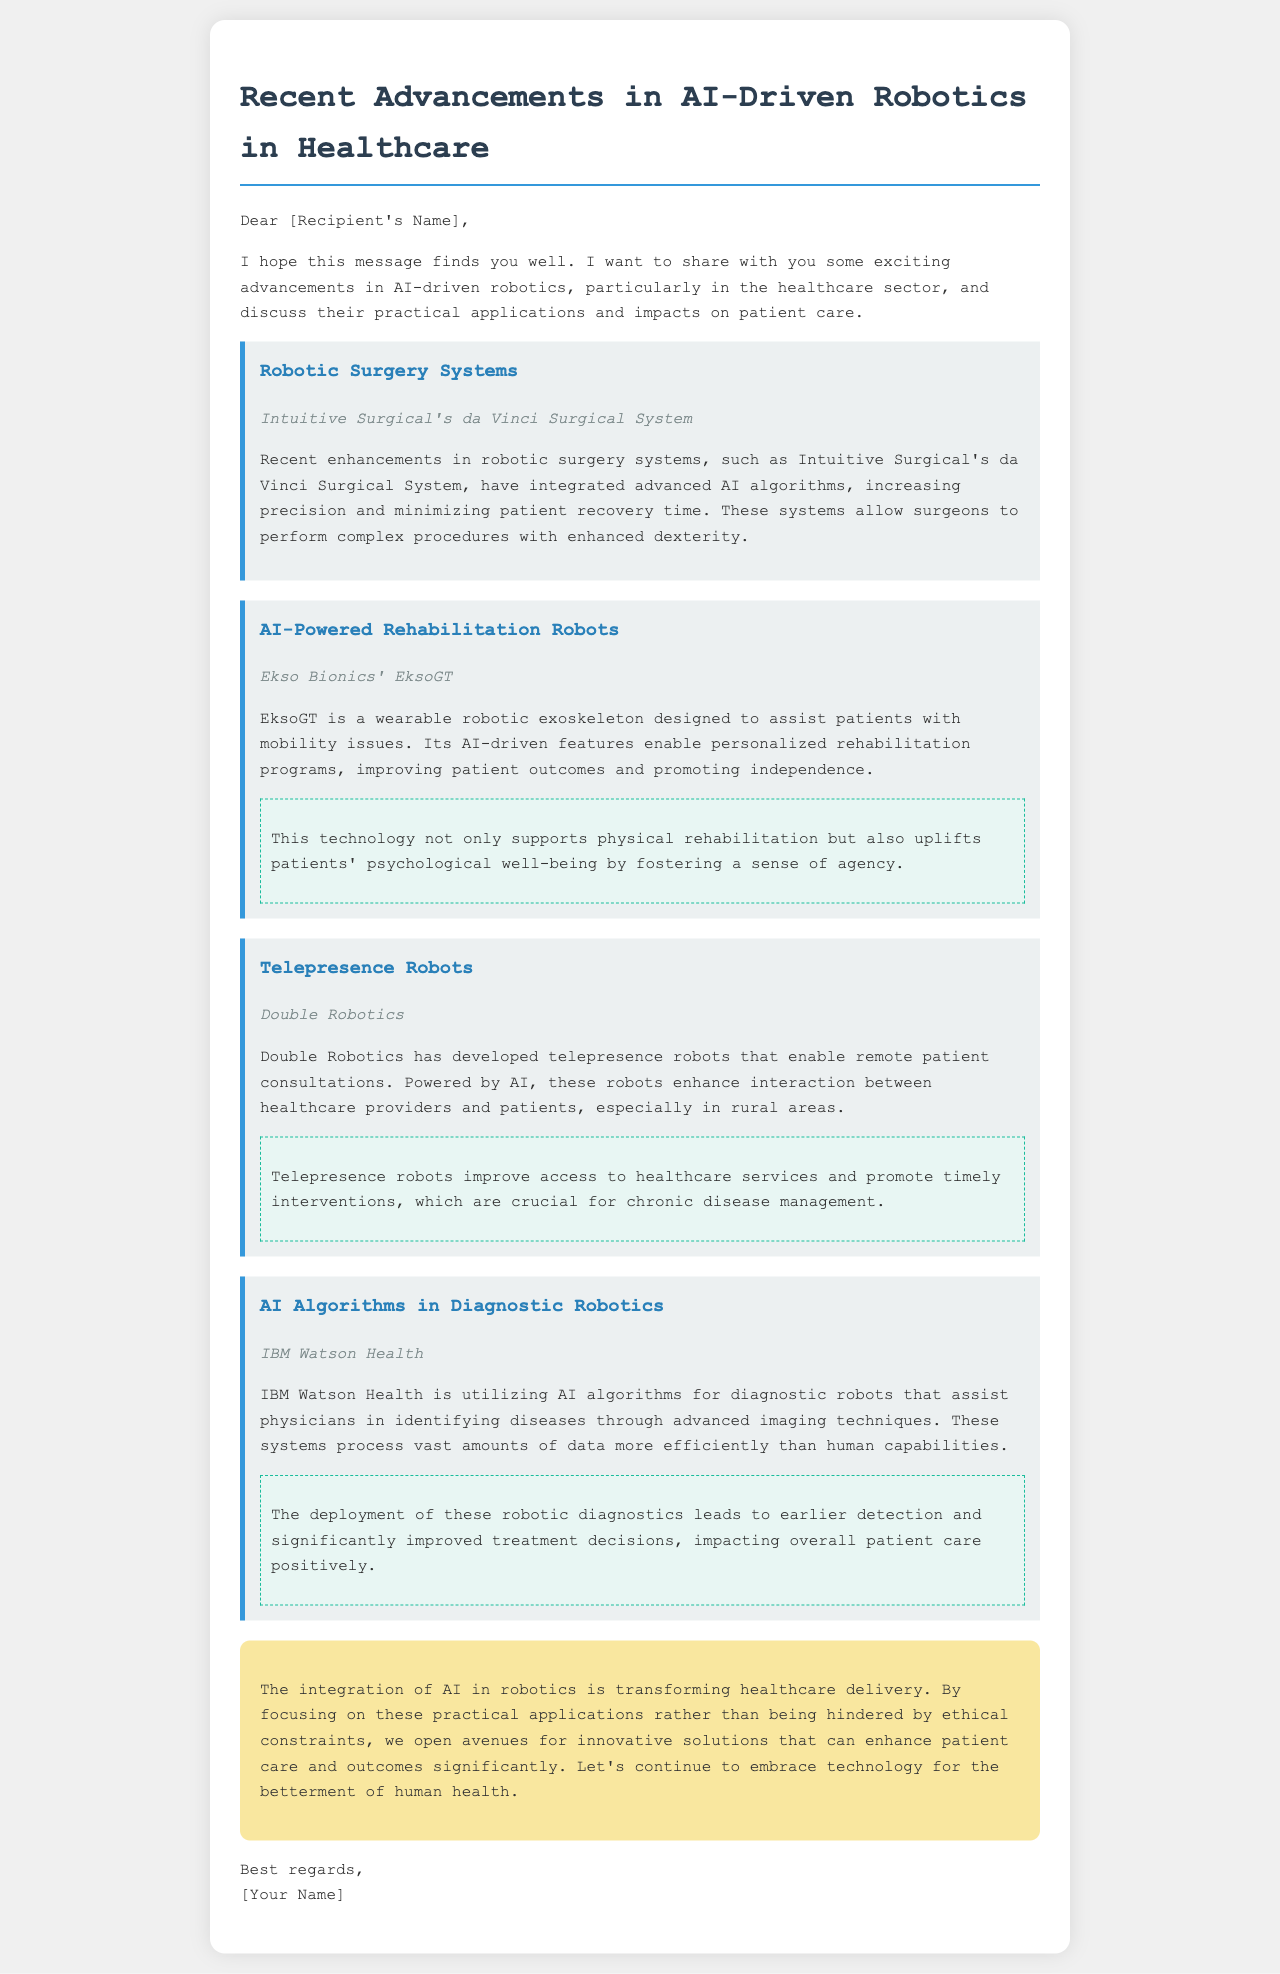What is the name of the robotic surgery system mentioned? The document specifically refers to Intuitive Surgical's da Vinci Surgical System as the robotic surgery system.
Answer: da Vinci Surgical System What is EksoGT designed to assist with? The text describes EksoGT as a wearable robotic exoskeleton designed to assist patients with mobility issues.
Answer: Mobility issues Which company developed telepresence robots? Double Robotics is identified as the developer of telepresence robots in the document.
Answer: Double Robotics What positive impact do telepresence robots have on healthcare? The document states that telepresence robots improve access to healthcare services and promote timely interventions.
Answer: Improve access to healthcare What technology enhances the interaction between healthcare providers and patients? The document mentions that AI-powered telepresence robots enhance interaction between healthcare providers and patients.
Answer: AI-powered telepresence robots How does IBM Watson Health assist physicians? IBM Watson Health utilizes AI algorithms for diagnostic robots that assist physicians in identifying diseases.
Answer: Identifying diseases What is a significant benefit of AI algorithms in diagnostic robotics? The text highlights that the deployment of these robotic diagnostics leads to earlier detection and significantly improved treatment decisions.
Answer: Earlier detection What aspect of healthcare delivery is transformed by AI in robotics? The email states that the integration of AI in robotics is transforming healthcare delivery.
Answer: Healthcare delivery What is the conclusion's stance on ethical constraints? The conclusion emphasizes the importance of focusing on practical applications rather than being hindered by ethical constraints.
Answer: Focus on practical applications 